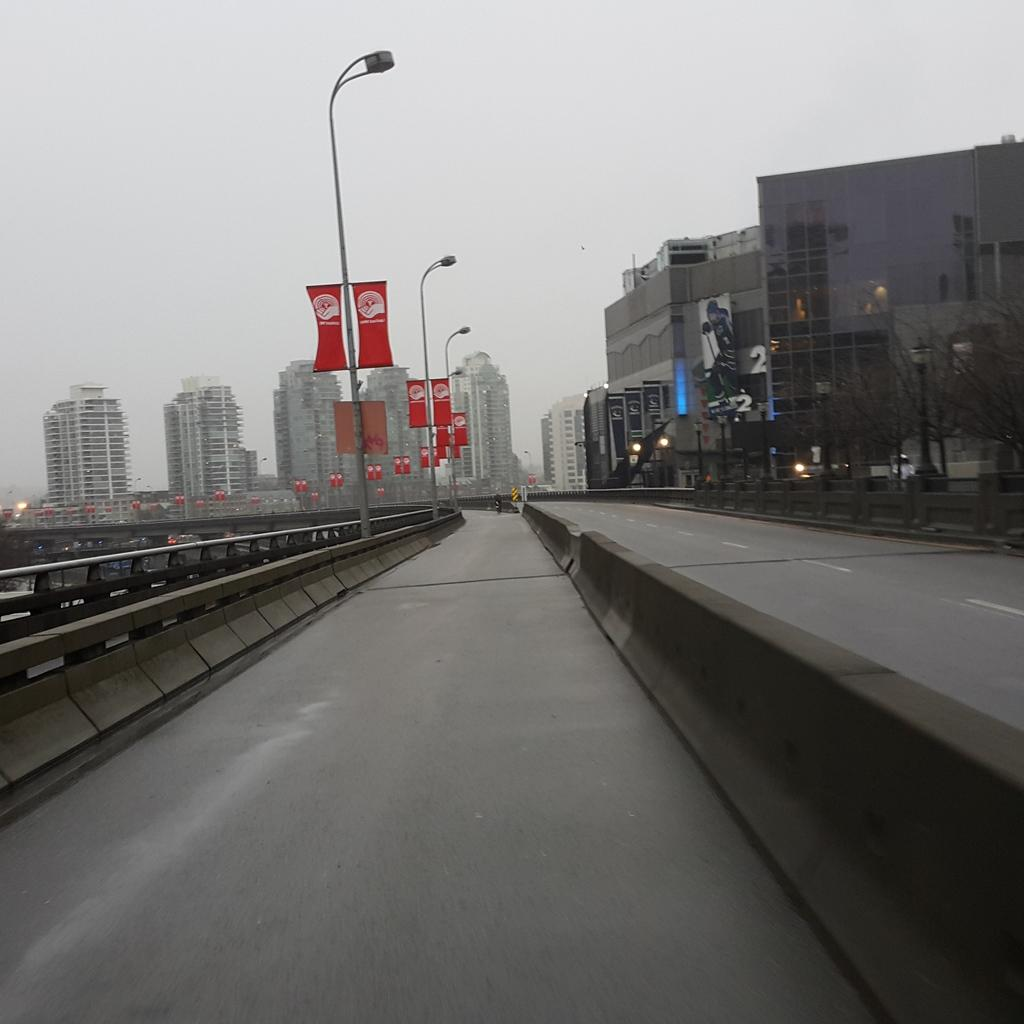What type of infrastructure is visible in the image? There are roads in the image. What accompanies the roads in the image? There are street light poles beside the roads. What can be seen in the background of the image? There are buildings in the background of the image. What is visible at the top of the image? The sky is visible at the top of the image. What is located to the left in the image? There is a railing to the left in the image. How many geese are flying over the buildings in the image? There are no geese visible in the image; it only features roads, street light poles, buildings, the sky, and a railing. 